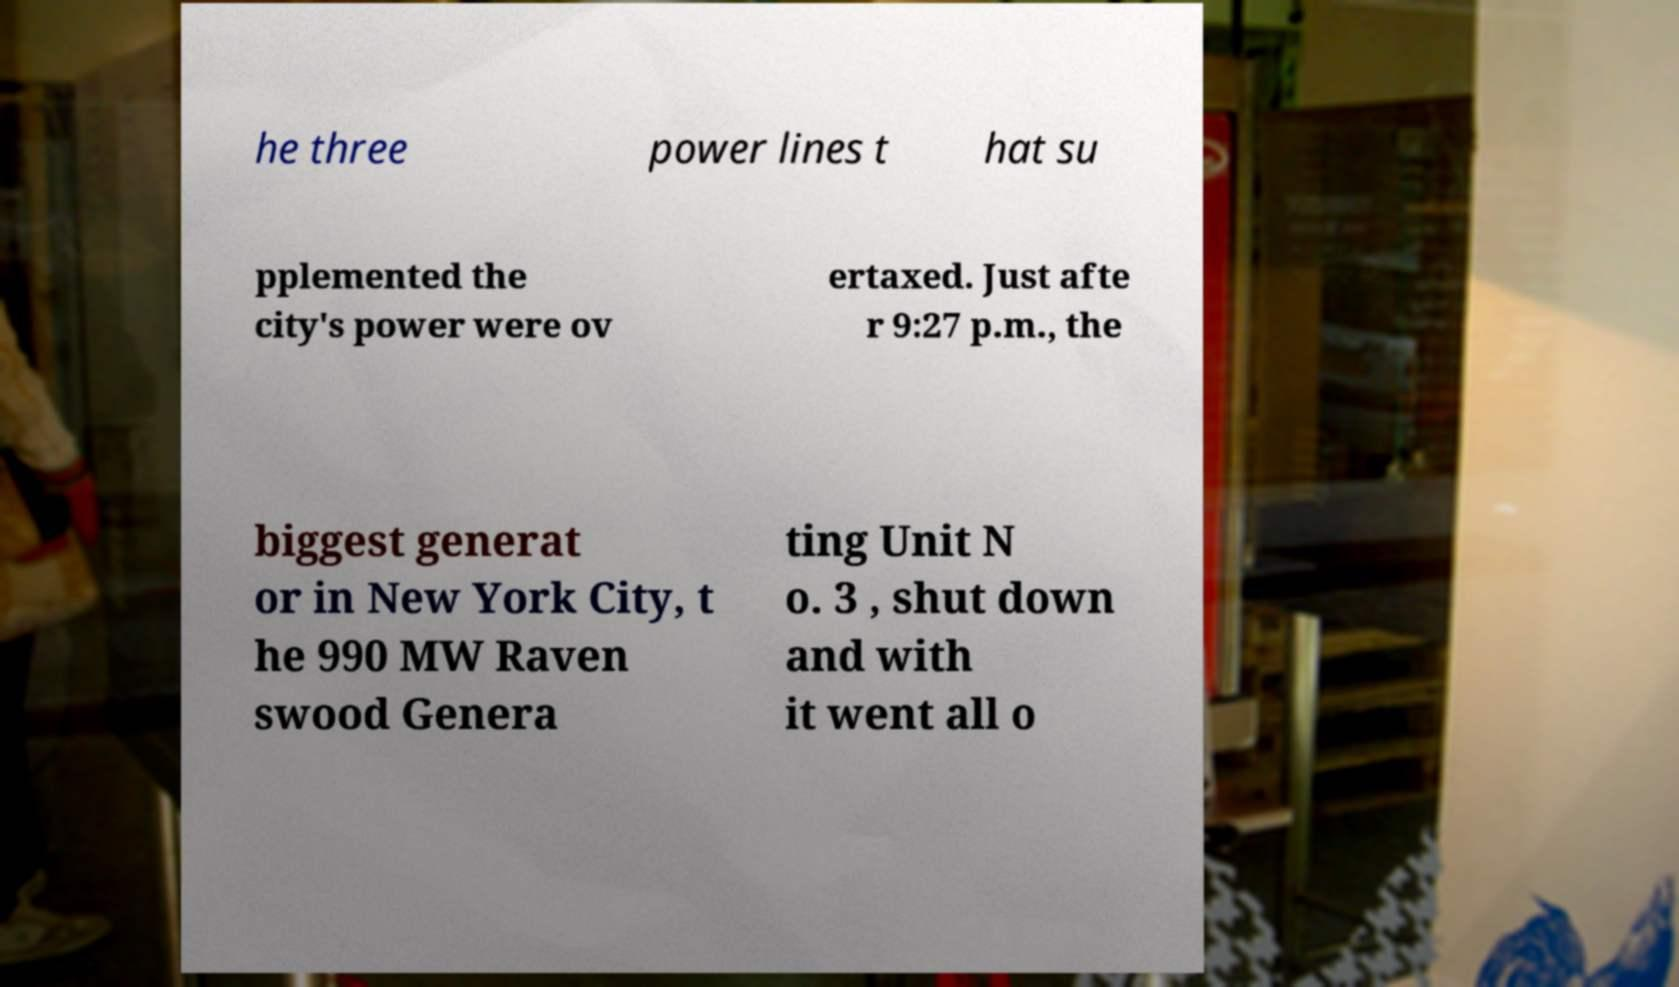What messages or text are displayed in this image? I need them in a readable, typed format. he three power lines t hat su pplemented the city's power were ov ertaxed. Just afte r 9:27 p.m., the biggest generat or in New York City, t he 990 MW Raven swood Genera ting Unit N o. 3 , shut down and with it went all o 